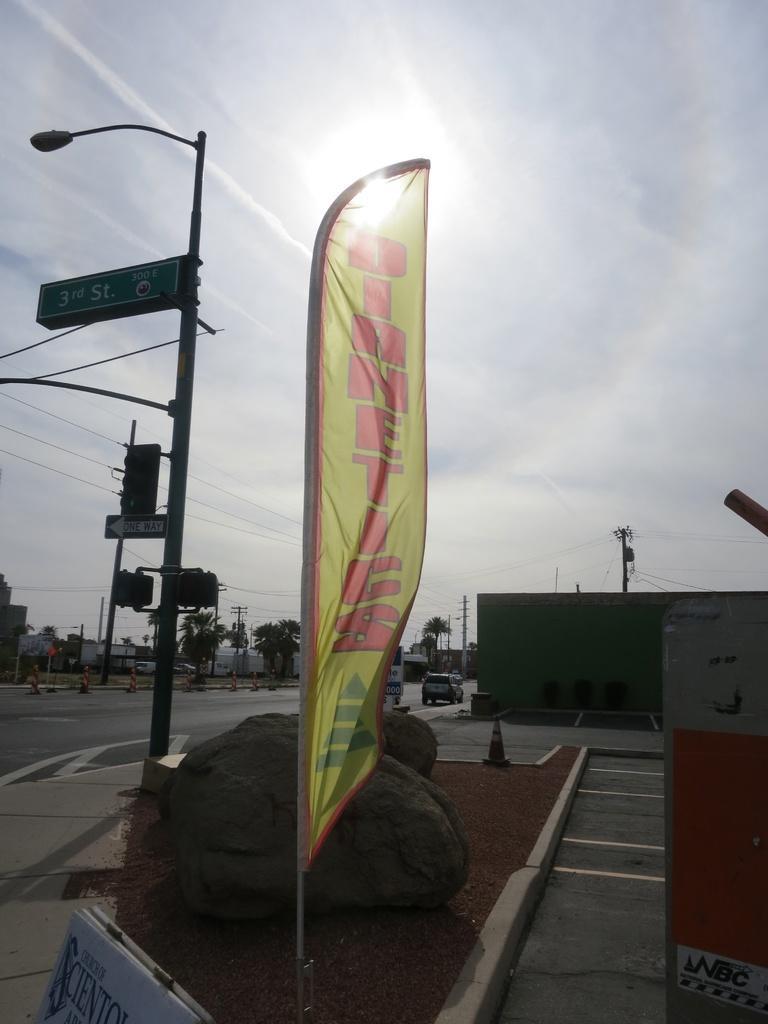Please provide a concise description of this image. In the middle of the image there are some banners. Behind the banners there are some poles and sign boards and trees and buildings and vehicles. At the top of the image there is sky and clouds and sun. 